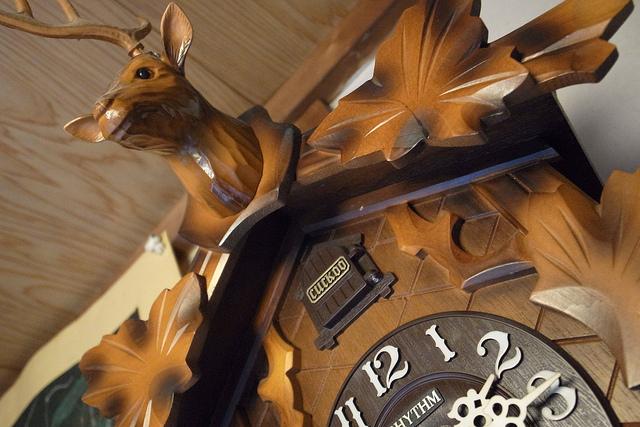Is the clock inside or out?
Be succinct. Inside. What number is the small hand on?
Write a very short answer. 2. What is behind the little door?
Concise answer only. Bird. 